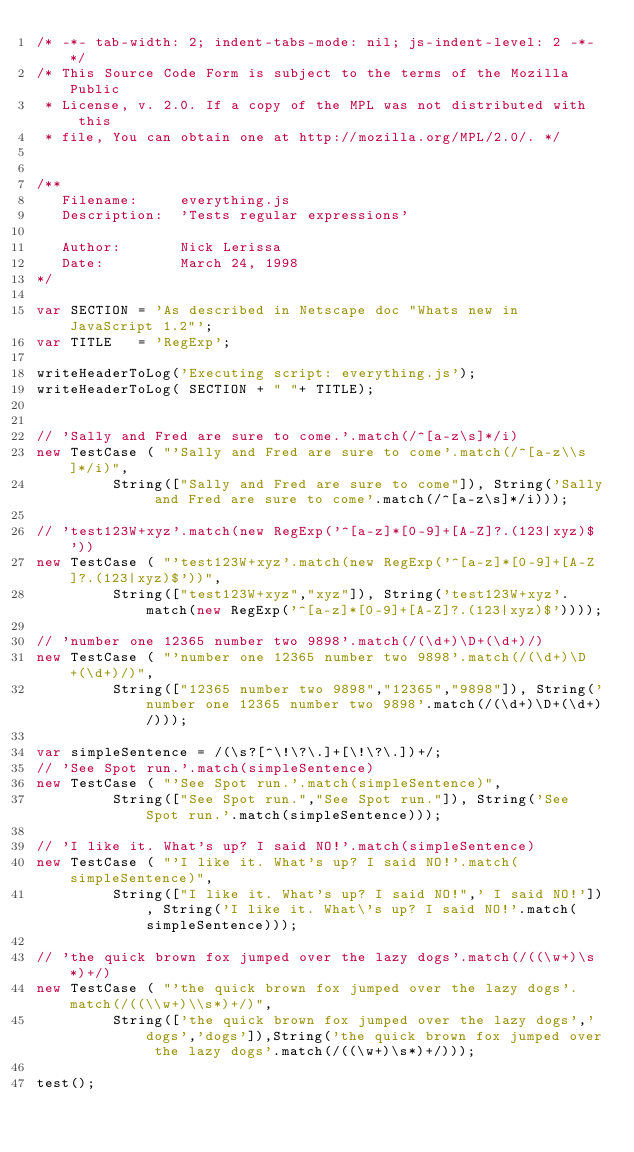<code> <loc_0><loc_0><loc_500><loc_500><_JavaScript_>/* -*- tab-width: 2; indent-tabs-mode: nil; js-indent-level: 2 -*- */
/* This Source Code Form is subject to the terms of the Mozilla Public
 * License, v. 2.0. If a copy of the MPL was not distributed with this
 * file, You can obtain one at http://mozilla.org/MPL/2.0/. */


/**
   Filename:     everything.js
   Description:  'Tests regular expressions'

   Author:       Nick Lerissa
   Date:         March 24, 1998
*/

var SECTION = 'As described in Netscape doc "Whats new in JavaScript 1.2"';
var TITLE   = 'RegExp';

writeHeaderToLog('Executing script: everything.js');
writeHeaderToLog( SECTION + " "+ TITLE);


// 'Sally and Fred are sure to come.'.match(/^[a-z\s]*/i)
new TestCase ( "'Sally and Fred are sure to come'.match(/^[a-z\\s]*/i)",
	       String(["Sally and Fred are sure to come"]), String('Sally and Fred are sure to come'.match(/^[a-z\s]*/i)));

// 'test123W+xyz'.match(new RegExp('^[a-z]*[0-9]+[A-Z]?.(123|xyz)$'))
new TestCase ( "'test123W+xyz'.match(new RegExp('^[a-z]*[0-9]+[A-Z]?.(123|xyz)$'))",
	       String(["test123W+xyz","xyz"]), String('test123W+xyz'.match(new RegExp('^[a-z]*[0-9]+[A-Z]?.(123|xyz)$'))));

// 'number one 12365 number two 9898'.match(/(\d+)\D+(\d+)/)
new TestCase ( "'number one 12365 number two 9898'.match(/(\d+)\D+(\d+)/)",
	       String(["12365 number two 9898","12365","9898"]), String('number one 12365 number two 9898'.match(/(\d+)\D+(\d+)/)));

var simpleSentence = /(\s?[^\!\?\.]+[\!\?\.])+/;
// 'See Spot run.'.match(simpleSentence)
new TestCase ( "'See Spot run.'.match(simpleSentence)",
	       String(["See Spot run.","See Spot run."]), String('See Spot run.'.match(simpleSentence)));

// 'I like it. What's up? I said NO!'.match(simpleSentence)
new TestCase ( "'I like it. What's up? I said NO!'.match(simpleSentence)",
	       String(["I like it. What's up? I said NO!",' I said NO!']), String('I like it. What\'s up? I said NO!'.match(simpleSentence)));

// 'the quick brown fox jumped over the lazy dogs'.match(/((\w+)\s*)+/)
new TestCase ( "'the quick brown fox jumped over the lazy dogs'.match(/((\\w+)\\s*)+/)",
	       String(['the quick brown fox jumped over the lazy dogs','dogs','dogs']),String('the quick brown fox jumped over the lazy dogs'.match(/((\w+)\s*)+/)));

test();
</code> 